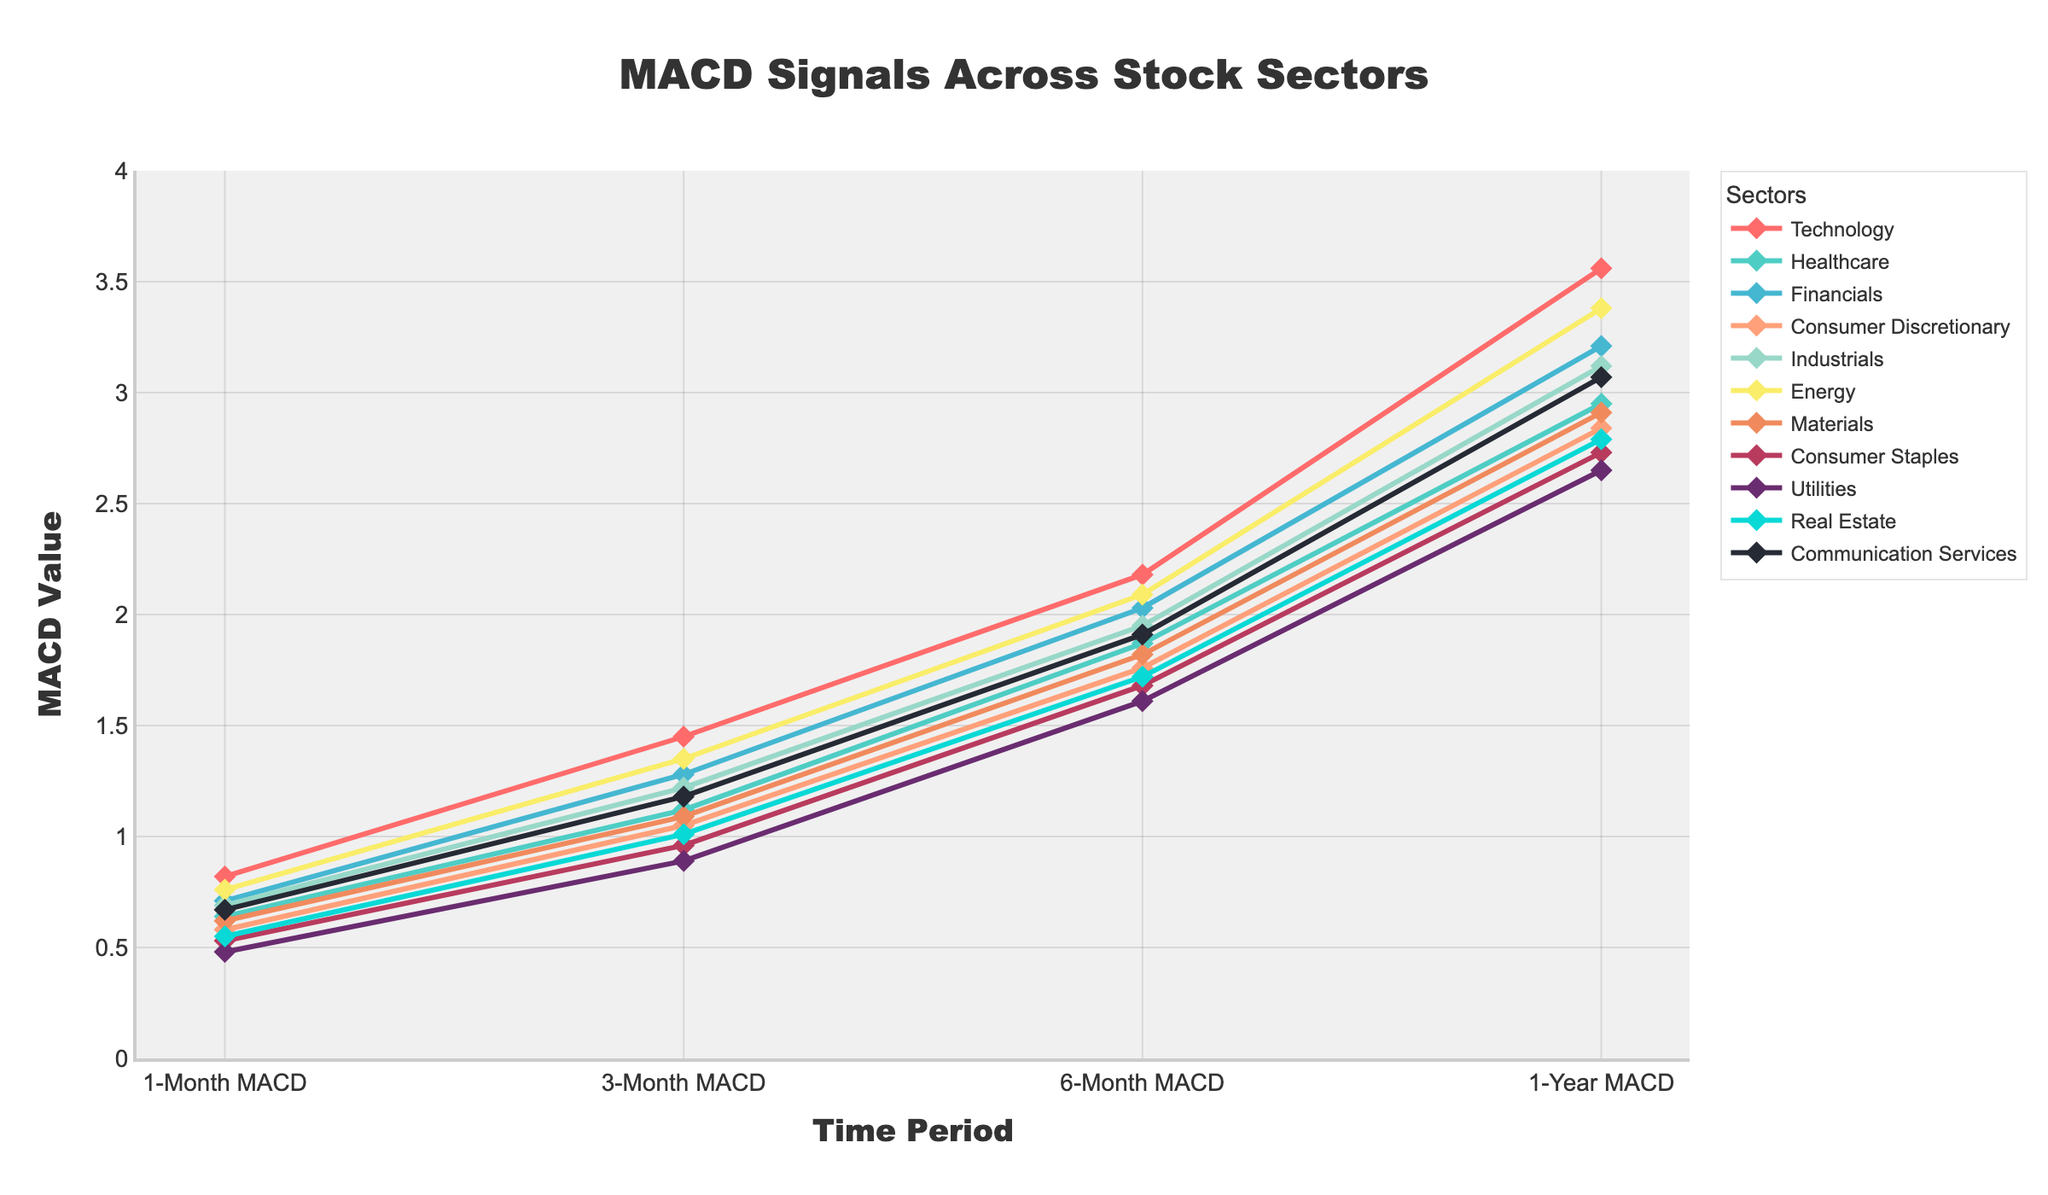Which sector shows the highest 1-Year MACD value? First, look at the 1-Year MACD values for all sectors. The highest value is 3.56, which corresponds to the Technology sector.
Answer: Technology By how much does the 3-Month MACD of Financials differ from that of Healthcare? Locate the 3-Month MACD values for Financials and Healthcare. Financials has 1.28 and Healthcare has 1.12. Subtracting these gives 1.28 - 1.12 = 0.16.
Answer: 0.16 What is the average 1-Month MACD value across all sectors? Sum up all the 1-Month MACD values and then divide by the number of sectors. The sum is \(0.82+0.64+0.71+0.58+0.69+0.76+0.62+0.53+0.48+0.55+0.67 = 7.05\). There are 11 sectors, so the average is \(7.05/11 ≈ 0.64\).
Answer: 0.64 Which two sectors have the closest 6-Month MACD values? Look at the 6-Month MACD column and identify the pairs with the smallest difference. Materials have 1.82 and Consumer Discretionary has 1.76, with a difference of 0.06, the smallest among all pairs.
Answer: Materials and Consumer Discretionary What is the total 1-Year MACD value for Energy and Utilities sectors combined? Add the 1-Year MACD values of Energy and Utilities directly. Energy has 3.38 and Utilities have 2.65. So, 3.38 + 2.65 = 6.03.
Answer: 6.03 Which sector has the steepest increase from 1-Month MACD to 1-Year MACD? Calculate the increase for each sector by subtracting the 1-Month MACD from the 1-Year MACD. Technology has the steepest increase: \(3.56 - 0.82 = 2.74\), which is the highest among all sectors.
Answer: Technology Compare Technology and Consumer Staples in terms of their 1-Year MACD values. Which is greater and by how much? The 1-Year MACD for Technology is 3.56 and for Consumer Staples is 2.73. The difference is \(3.56 - 2.73 = 0.83\). Technology's value is greater by 0.83.
Answer: Technology, 0.83 What is the range of the 3-Month MACD across all sectors? Find the minimum and maximum 3-Month MACD values. The minimum is 0.89 (Utilities) and the maximum is 1.45 (Technology). The range is \(1.45 - 0.89 = 0.56\).
Answer: 0.56 How does the 1-Month MACD value of Communication Services compare with that of Real Estate? The 1-Month MACD for Communication Services is 0.67 and for Real Estate is 0.55. Comparison shows 0.67 is greater than 0.55.
Answer: Communication Services is greater What's the median 6-Month MACD value across all sectors? Organize the 6-Month MACD values in ascending order: [1.61, 1.68, 1.72, 1.76, 1.82, 1.87, 1.91, 1.95, 2.03, 2.09, 2.18]. The middle value in this list is 1.87, which is the 6th value.
Answer: 1.87 